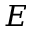<formula> <loc_0><loc_0><loc_500><loc_500>E</formula> 